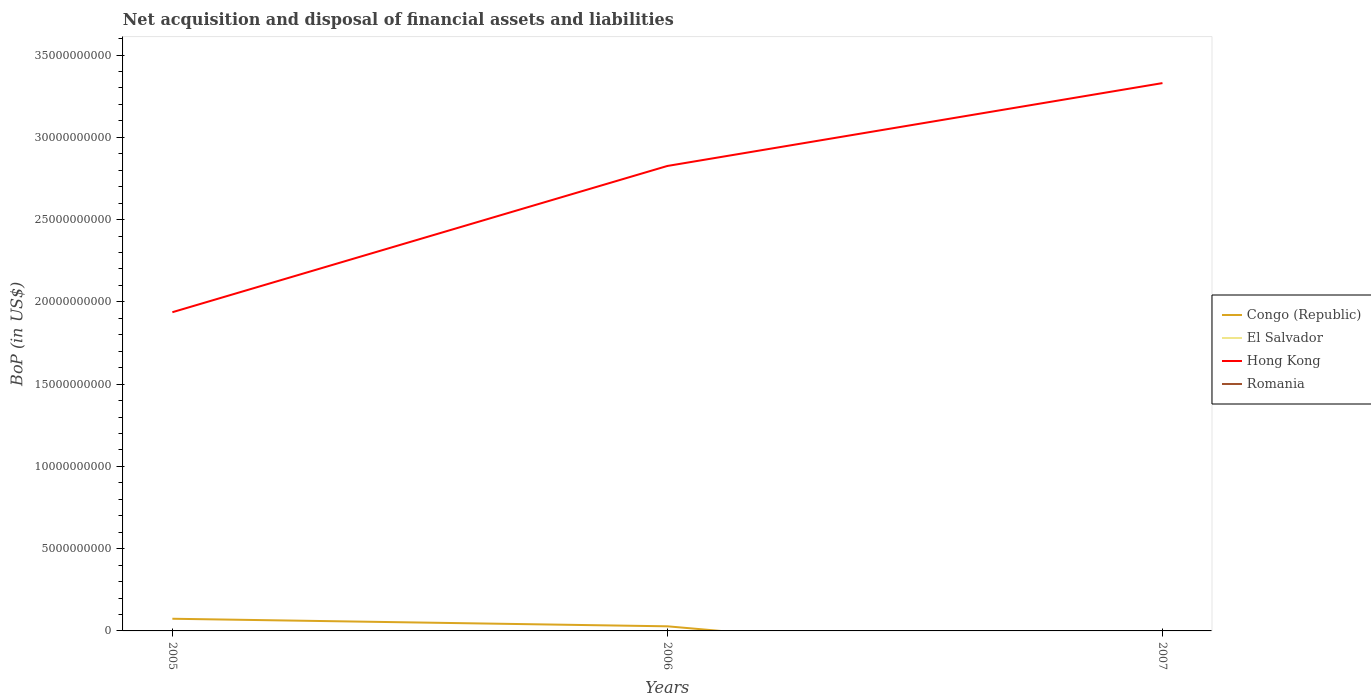Does the line corresponding to El Salvador intersect with the line corresponding to Congo (Republic)?
Your answer should be compact. Yes. Is the number of lines equal to the number of legend labels?
Offer a terse response. No. Across all years, what is the maximum Balance of Payments in Congo (Republic)?
Your answer should be very brief. 0. What is the total Balance of Payments in Hong Kong in the graph?
Your answer should be compact. -8.89e+09. What is the difference between the highest and the second highest Balance of Payments in Hong Kong?
Provide a succinct answer. 1.39e+1. How many years are there in the graph?
Ensure brevity in your answer.  3. Does the graph contain any zero values?
Make the answer very short. Yes. Does the graph contain grids?
Ensure brevity in your answer.  No. Where does the legend appear in the graph?
Your answer should be very brief. Center right. How are the legend labels stacked?
Offer a very short reply. Vertical. What is the title of the graph?
Ensure brevity in your answer.  Net acquisition and disposal of financial assets and liabilities. What is the label or title of the Y-axis?
Offer a terse response. BoP (in US$). What is the BoP (in US$) of Congo (Republic) in 2005?
Offer a terse response. 7.40e+08. What is the BoP (in US$) of Hong Kong in 2005?
Provide a succinct answer. 1.94e+1. What is the BoP (in US$) in Congo (Republic) in 2006?
Offer a very short reply. 2.80e+08. What is the BoP (in US$) in El Salvador in 2006?
Your answer should be very brief. 0. What is the BoP (in US$) of Hong Kong in 2006?
Offer a terse response. 2.83e+1. What is the BoP (in US$) of Romania in 2006?
Offer a very short reply. 0. What is the BoP (in US$) of Congo (Republic) in 2007?
Your answer should be very brief. 0. What is the BoP (in US$) of El Salvador in 2007?
Your response must be concise. 0. What is the BoP (in US$) in Hong Kong in 2007?
Make the answer very short. 3.33e+1. What is the BoP (in US$) in Romania in 2007?
Your answer should be compact. 0. Across all years, what is the maximum BoP (in US$) in Congo (Republic)?
Make the answer very short. 7.40e+08. Across all years, what is the maximum BoP (in US$) of Hong Kong?
Offer a terse response. 3.33e+1. Across all years, what is the minimum BoP (in US$) in Hong Kong?
Offer a very short reply. 1.94e+1. What is the total BoP (in US$) in Congo (Republic) in the graph?
Make the answer very short. 1.02e+09. What is the total BoP (in US$) in El Salvador in the graph?
Offer a very short reply. 0. What is the total BoP (in US$) of Hong Kong in the graph?
Give a very brief answer. 8.09e+1. What is the total BoP (in US$) in Romania in the graph?
Provide a short and direct response. 0. What is the difference between the BoP (in US$) in Congo (Republic) in 2005 and that in 2006?
Make the answer very short. 4.60e+08. What is the difference between the BoP (in US$) in Hong Kong in 2005 and that in 2006?
Your answer should be very brief. -8.89e+09. What is the difference between the BoP (in US$) in Hong Kong in 2005 and that in 2007?
Offer a very short reply. -1.39e+1. What is the difference between the BoP (in US$) in Hong Kong in 2006 and that in 2007?
Make the answer very short. -5.04e+09. What is the difference between the BoP (in US$) in Congo (Republic) in 2005 and the BoP (in US$) in Hong Kong in 2006?
Ensure brevity in your answer.  -2.75e+1. What is the difference between the BoP (in US$) in Congo (Republic) in 2005 and the BoP (in US$) in Hong Kong in 2007?
Provide a succinct answer. -3.26e+1. What is the difference between the BoP (in US$) of Congo (Republic) in 2006 and the BoP (in US$) of Hong Kong in 2007?
Give a very brief answer. -3.30e+1. What is the average BoP (in US$) of Congo (Republic) per year?
Offer a terse response. 3.40e+08. What is the average BoP (in US$) of Hong Kong per year?
Provide a short and direct response. 2.70e+1. What is the average BoP (in US$) of Romania per year?
Your answer should be very brief. 0. In the year 2005, what is the difference between the BoP (in US$) in Congo (Republic) and BoP (in US$) in Hong Kong?
Provide a short and direct response. -1.86e+1. In the year 2006, what is the difference between the BoP (in US$) of Congo (Republic) and BoP (in US$) of Hong Kong?
Your response must be concise. -2.80e+1. What is the ratio of the BoP (in US$) in Congo (Republic) in 2005 to that in 2006?
Ensure brevity in your answer.  2.64. What is the ratio of the BoP (in US$) in Hong Kong in 2005 to that in 2006?
Your response must be concise. 0.69. What is the ratio of the BoP (in US$) of Hong Kong in 2005 to that in 2007?
Offer a very short reply. 0.58. What is the ratio of the BoP (in US$) in Hong Kong in 2006 to that in 2007?
Make the answer very short. 0.85. What is the difference between the highest and the second highest BoP (in US$) in Hong Kong?
Ensure brevity in your answer.  5.04e+09. What is the difference between the highest and the lowest BoP (in US$) in Congo (Republic)?
Provide a succinct answer. 7.40e+08. What is the difference between the highest and the lowest BoP (in US$) in Hong Kong?
Give a very brief answer. 1.39e+1. 